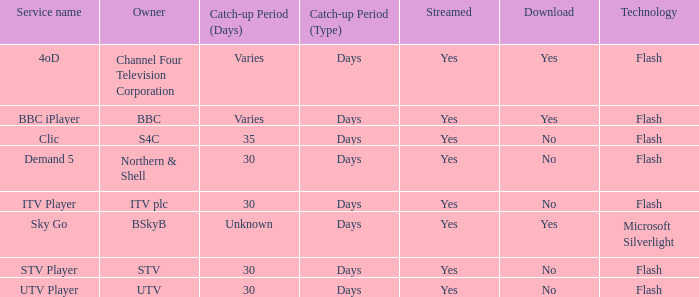What is the download of the varies catch-up period? Yes, Yes. 